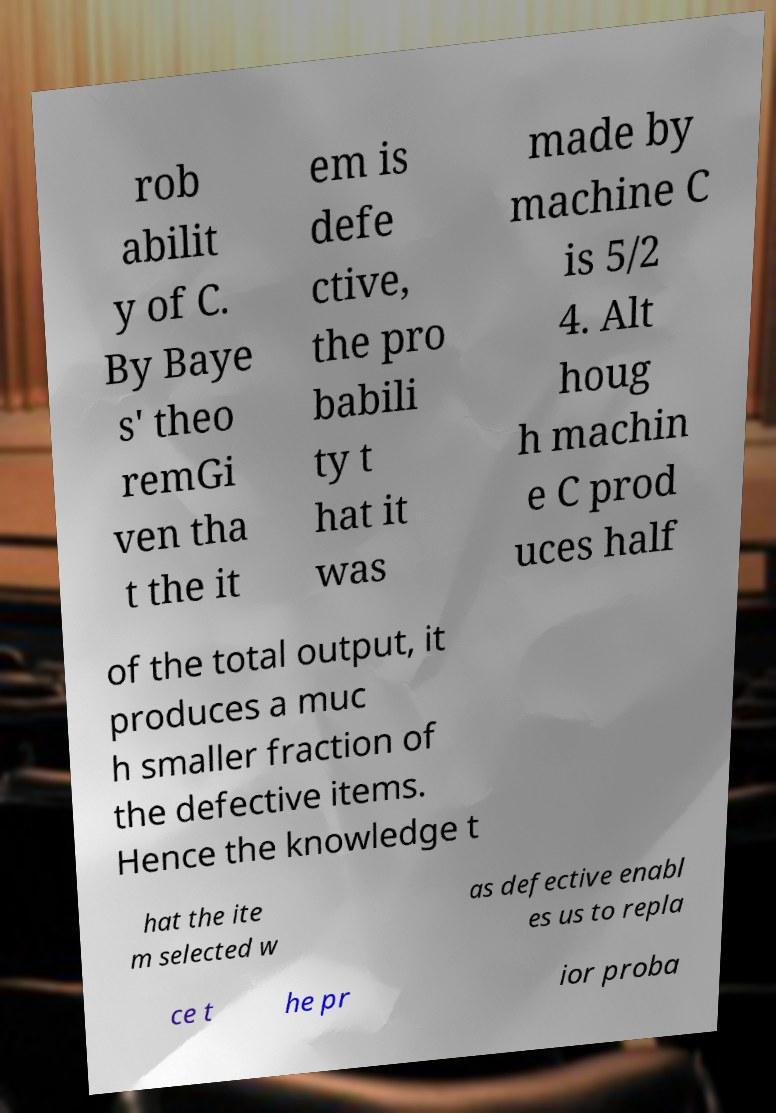There's text embedded in this image that I need extracted. Can you transcribe it verbatim? rob abilit y of C. By Baye s' theo remGi ven tha t the it em is defe ctive, the pro babili ty t hat it was made by machine C is 5/2 4. Alt houg h machin e C prod uces half of the total output, it produces a muc h smaller fraction of the defective items. Hence the knowledge t hat the ite m selected w as defective enabl es us to repla ce t he pr ior proba 